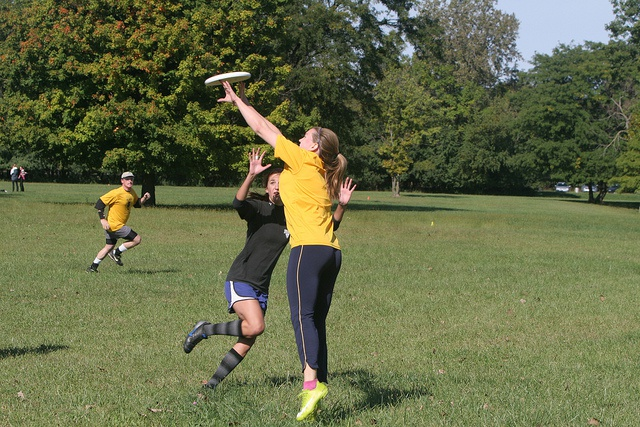Describe the objects in this image and their specific colors. I can see people in darkgreen, gold, black, and gray tones, people in darkgreen, black, gray, olive, and lightpink tones, people in darkgreen, black, gray, olive, and gold tones, frisbee in darkgreen, white, olive, black, and maroon tones, and people in darkgreen, black, brown, and lightpink tones in this image. 